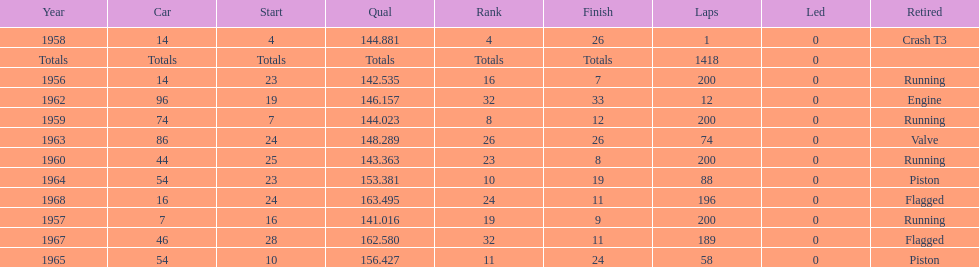In how many instances did he finish in a position greater than 10th? 3. 